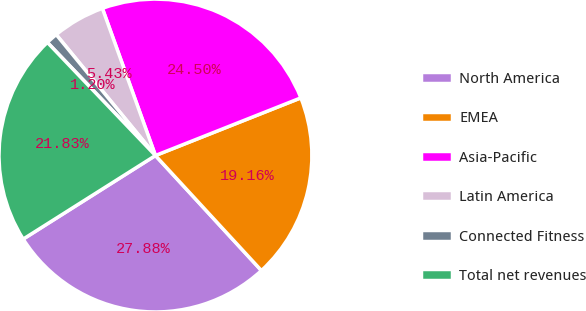Convert chart to OTSL. <chart><loc_0><loc_0><loc_500><loc_500><pie_chart><fcel>North America<fcel>EMEA<fcel>Asia-Pacific<fcel>Latin America<fcel>Connected Fitness<fcel>Total net revenues<nl><fcel>27.88%<fcel>19.16%<fcel>24.5%<fcel>5.43%<fcel>1.2%<fcel>21.83%<nl></chart> 